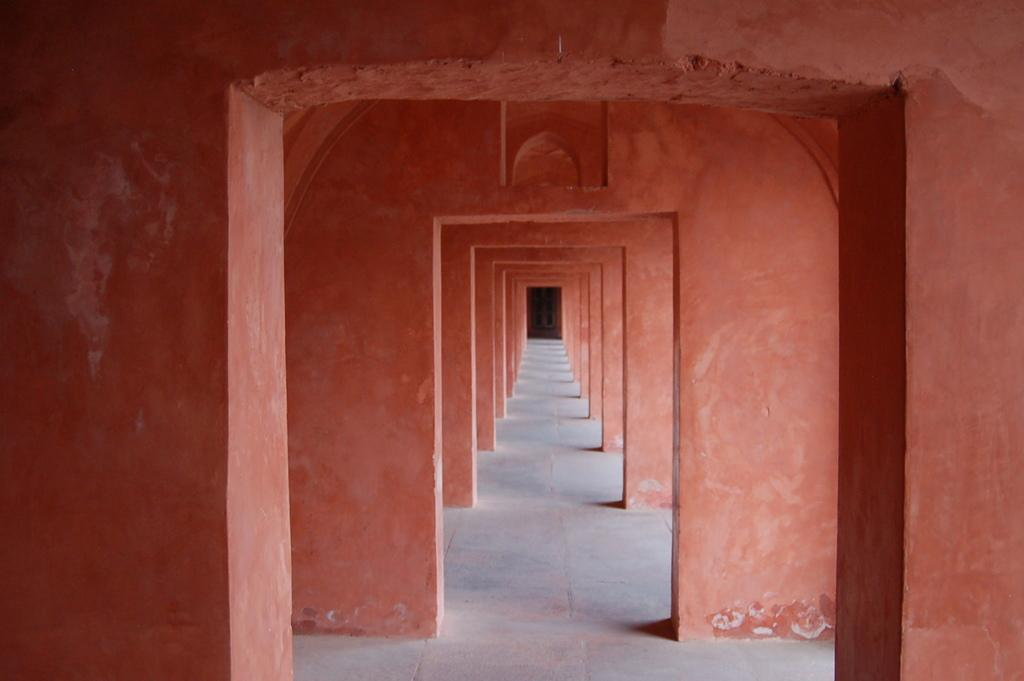What type of openings can be seen on the floor in the image? There are entrances on the floor in the image. Can you describe any other type of opening in the image? Yes, there is a door visible in the image. Is there an argument taking place near the entrances in the image? There is no indication of an argument in the image; it only shows entrances on the floor and a door. 